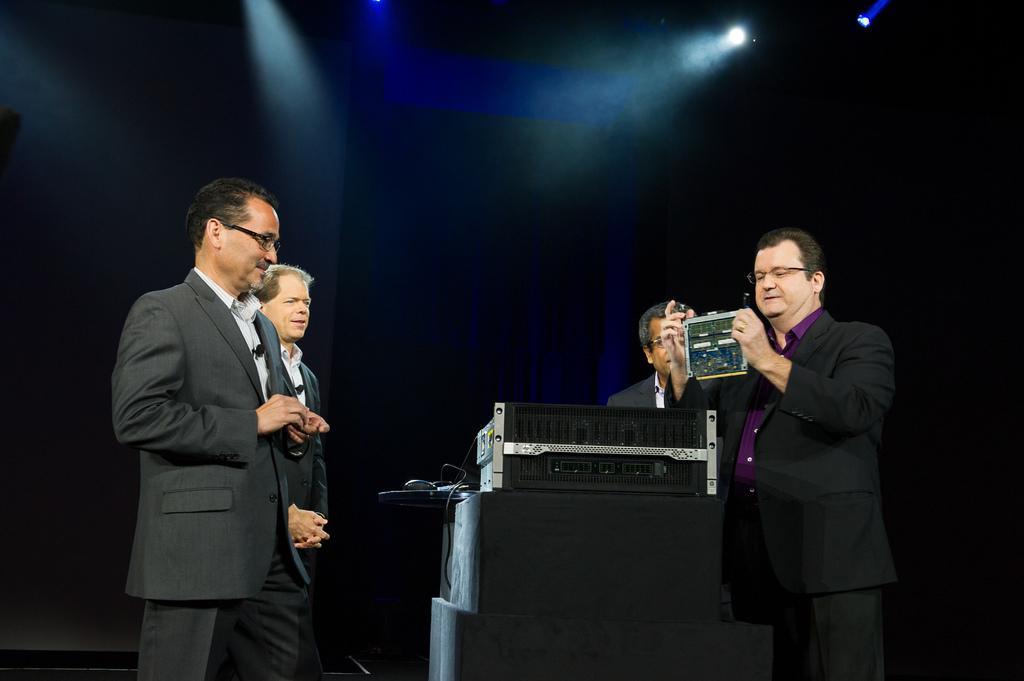Could you give a brief overview of what you see in this image? There are four men standing and in the middle there is an electric device on a platform and on the right a man is holding an object in his hands. In the background there are lights. 